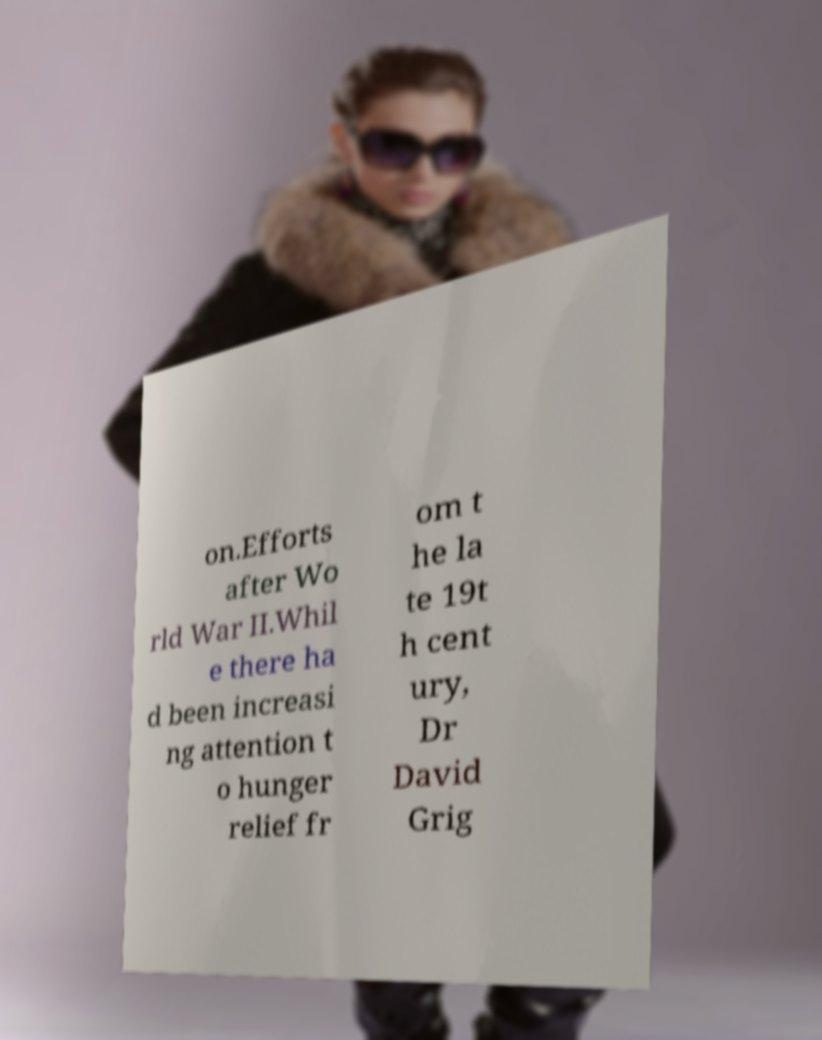Could you extract and type out the text from this image? on.Efforts after Wo rld War II.Whil e there ha d been increasi ng attention t o hunger relief fr om t he la te 19t h cent ury, Dr David Grig 